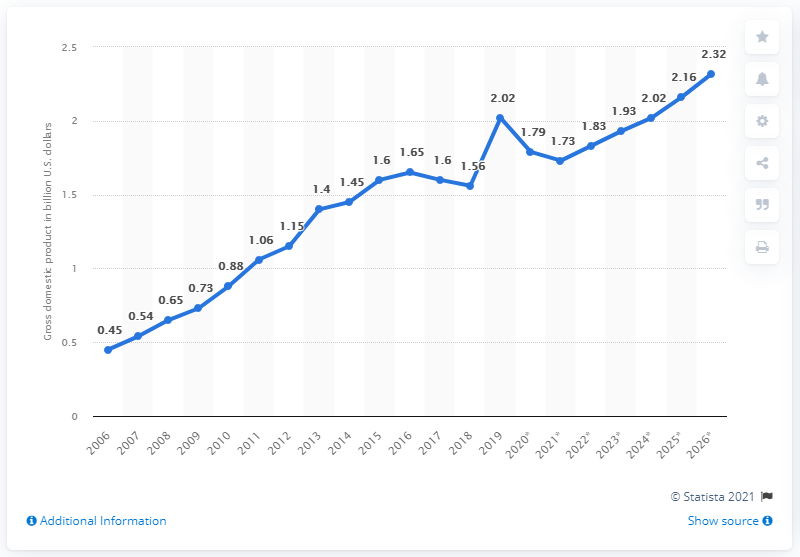Identify some key points in this picture. In 2019, the gross domestic product of Timor-Leste was 2.02 billion U.S. dollars. 